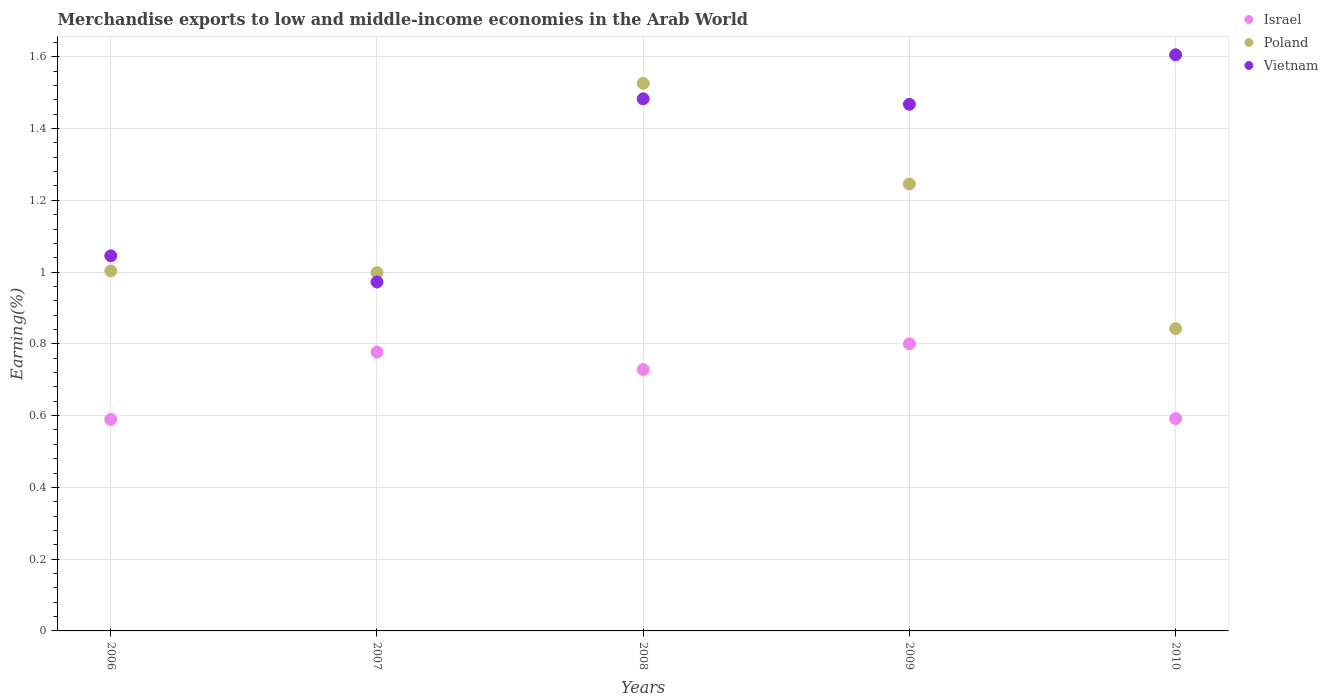How many different coloured dotlines are there?
Offer a very short reply. 3. Is the number of dotlines equal to the number of legend labels?
Offer a terse response. Yes. What is the percentage of amount earned from merchandise exports in Israel in 2006?
Give a very brief answer. 0.59. Across all years, what is the maximum percentage of amount earned from merchandise exports in Israel?
Provide a short and direct response. 0.8. Across all years, what is the minimum percentage of amount earned from merchandise exports in Poland?
Make the answer very short. 0.84. In which year was the percentage of amount earned from merchandise exports in Poland maximum?
Your answer should be very brief. 2008. What is the total percentage of amount earned from merchandise exports in Poland in the graph?
Give a very brief answer. 5.62. What is the difference between the percentage of amount earned from merchandise exports in Poland in 2007 and that in 2008?
Ensure brevity in your answer.  -0.53. What is the difference between the percentage of amount earned from merchandise exports in Vietnam in 2008 and the percentage of amount earned from merchandise exports in Israel in 2010?
Your response must be concise. 0.89. What is the average percentage of amount earned from merchandise exports in Vietnam per year?
Offer a very short reply. 1.31. In the year 2009, what is the difference between the percentage of amount earned from merchandise exports in Vietnam and percentage of amount earned from merchandise exports in Poland?
Give a very brief answer. 0.22. In how many years, is the percentage of amount earned from merchandise exports in Vietnam greater than 0.04 %?
Provide a short and direct response. 5. What is the ratio of the percentage of amount earned from merchandise exports in Israel in 2006 to that in 2010?
Ensure brevity in your answer.  1. Is the percentage of amount earned from merchandise exports in Vietnam in 2006 less than that in 2009?
Offer a very short reply. Yes. Is the difference between the percentage of amount earned from merchandise exports in Vietnam in 2006 and 2009 greater than the difference between the percentage of amount earned from merchandise exports in Poland in 2006 and 2009?
Make the answer very short. No. What is the difference between the highest and the second highest percentage of amount earned from merchandise exports in Vietnam?
Provide a succinct answer. 0.12. What is the difference between the highest and the lowest percentage of amount earned from merchandise exports in Poland?
Offer a very short reply. 0.68. Is the sum of the percentage of amount earned from merchandise exports in Israel in 2008 and 2009 greater than the maximum percentage of amount earned from merchandise exports in Vietnam across all years?
Your response must be concise. No. How many years are there in the graph?
Offer a very short reply. 5. Are the values on the major ticks of Y-axis written in scientific E-notation?
Offer a terse response. No. Does the graph contain any zero values?
Offer a terse response. No. Does the graph contain grids?
Your answer should be very brief. Yes. Where does the legend appear in the graph?
Your answer should be very brief. Top right. How many legend labels are there?
Provide a succinct answer. 3. How are the legend labels stacked?
Your answer should be compact. Vertical. What is the title of the graph?
Your answer should be compact. Merchandise exports to low and middle-income economies in the Arab World. Does "Curacao" appear as one of the legend labels in the graph?
Provide a short and direct response. No. What is the label or title of the Y-axis?
Ensure brevity in your answer.  Earning(%). What is the Earning(%) in Israel in 2006?
Keep it short and to the point. 0.59. What is the Earning(%) of Poland in 2006?
Provide a short and direct response. 1. What is the Earning(%) of Vietnam in 2006?
Keep it short and to the point. 1.05. What is the Earning(%) of Israel in 2007?
Your answer should be compact. 0.78. What is the Earning(%) in Poland in 2007?
Your answer should be compact. 1. What is the Earning(%) of Vietnam in 2007?
Your response must be concise. 0.97. What is the Earning(%) in Israel in 2008?
Your response must be concise. 0.73. What is the Earning(%) in Poland in 2008?
Provide a succinct answer. 1.53. What is the Earning(%) of Vietnam in 2008?
Your response must be concise. 1.48. What is the Earning(%) in Israel in 2009?
Offer a terse response. 0.8. What is the Earning(%) of Poland in 2009?
Make the answer very short. 1.25. What is the Earning(%) of Vietnam in 2009?
Offer a terse response. 1.47. What is the Earning(%) in Israel in 2010?
Make the answer very short. 0.59. What is the Earning(%) of Poland in 2010?
Your answer should be very brief. 0.84. What is the Earning(%) in Vietnam in 2010?
Provide a succinct answer. 1.61. Across all years, what is the maximum Earning(%) of Israel?
Ensure brevity in your answer.  0.8. Across all years, what is the maximum Earning(%) in Poland?
Make the answer very short. 1.53. Across all years, what is the maximum Earning(%) in Vietnam?
Your answer should be compact. 1.61. Across all years, what is the minimum Earning(%) in Israel?
Provide a short and direct response. 0.59. Across all years, what is the minimum Earning(%) in Poland?
Offer a terse response. 0.84. Across all years, what is the minimum Earning(%) in Vietnam?
Provide a succinct answer. 0.97. What is the total Earning(%) of Israel in the graph?
Your response must be concise. 3.49. What is the total Earning(%) of Poland in the graph?
Your response must be concise. 5.62. What is the total Earning(%) in Vietnam in the graph?
Provide a short and direct response. 6.57. What is the difference between the Earning(%) in Israel in 2006 and that in 2007?
Offer a terse response. -0.19. What is the difference between the Earning(%) in Poland in 2006 and that in 2007?
Provide a short and direct response. 0. What is the difference between the Earning(%) in Vietnam in 2006 and that in 2007?
Keep it short and to the point. 0.07. What is the difference between the Earning(%) of Israel in 2006 and that in 2008?
Provide a succinct answer. -0.14. What is the difference between the Earning(%) in Poland in 2006 and that in 2008?
Your answer should be compact. -0.52. What is the difference between the Earning(%) in Vietnam in 2006 and that in 2008?
Provide a short and direct response. -0.44. What is the difference between the Earning(%) of Israel in 2006 and that in 2009?
Provide a short and direct response. -0.21. What is the difference between the Earning(%) of Poland in 2006 and that in 2009?
Offer a terse response. -0.24. What is the difference between the Earning(%) of Vietnam in 2006 and that in 2009?
Your answer should be very brief. -0.42. What is the difference between the Earning(%) in Israel in 2006 and that in 2010?
Your answer should be very brief. -0. What is the difference between the Earning(%) of Poland in 2006 and that in 2010?
Give a very brief answer. 0.16. What is the difference between the Earning(%) of Vietnam in 2006 and that in 2010?
Your answer should be very brief. -0.56. What is the difference between the Earning(%) in Israel in 2007 and that in 2008?
Keep it short and to the point. 0.05. What is the difference between the Earning(%) of Poland in 2007 and that in 2008?
Provide a succinct answer. -0.53. What is the difference between the Earning(%) in Vietnam in 2007 and that in 2008?
Make the answer very short. -0.51. What is the difference between the Earning(%) of Israel in 2007 and that in 2009?
Provide a succinct answer. -0.02. What is the difference between the Earning(%) in Poland in 2007 and that in 2009?
Ensure brevity in your answer.  -0.25. What is the difference between the Earning(%) in Vietnam in 2007 and that in 2009?
Your answer should be compact. -0.5. What is the difference between the Earning(%) in Israel in 2007 and that in 2010?
Your response must be concise. 0.19. What is the difference between the Earning(%) in Poland in 2007 and that in 2010?
Keep it short and to the point. 0.16. What is the difference between the Earning(%) in Vietnam in 2007 and that in 2010?
Give a very brief answer. -0.63. What is the difference between the Earning(%) of Israel in 2008 and that in 2009?
Give a very brief answer. -0.07. What is the difference between the Earning(%) of Poland in 2008 and that in 2009?
Ensure brevity in your answer.  0.28. What is the difference between the Earning(%) in Vietnam in 2008 and that in 2009?
Give a very brief answer. 0.02. What is the difference between the Earning(%) in Israel in 2008 and that in 2010?
Your answer should be compact. 0.14. What is the difference between the Earning(%) of Poland in 2008 and that in 2010?
Your answer should be very brief. 0.68. What is the difference between the Earning(%) in Vietnam in 2008 and that in 2010?
Offer a terse response. -0.12. What is the difference between the Earning(%) in Israel in 2009 and that in 2010?
Provide a short and direct response. 0.21. What is the difference between the Earning(%) of Poland in 2009 and that in 2010?
Keep it short and to the point. 0.4. What is the difference between the Earning(%) in Vietnam in 2009 and that in 2010?
Your response must be concise. -0.14. What is the difference between the Earning(%) of Israel in 2006 and the Earning(%) of Poland in 2007?
Ensure brevity in your answer.  -0.41. What is the difference between the Earning(%) of Israel in 2006 and the Earning(%) of Vietnam in 2007?
Your answer should be very brief. -0.38. What is the difference between the Earning(%) of Poland in 2006 and the Earning(%) of Vietnam in 2007?
Provide a succinct answer. 0.03. What is the difference between the Earning(%) of Israel in 2006 and the Earning(%) of Poland in 2008?
Provide a short and direct response. -0.94. What is the difference between the Earning(%) in Israel in 2006 and the Earning(%) in Vietnam in 2008?
Keep it short and to the point. -0.89. What is the difference between the Earning(%) of Poland in 2006 and the Earning(%) of Vietnam in 2008?
Give a very brief answer. -0.48. What is the difference between the Earning(%) in Israel in 2006 and the Earning(%) in Poland in 2009?
Your answer should be compact. -0.66. What is the difference between the Earning(%) in Israel in 2006 and the Earning(%) in Vietnam in 2009?
Give a very brief answer. -0.88. What is the difference between the Earning(%) of Poland in 2006 and the Earning(%) of Vietnam in 2009?
Keep it short and to the point. -0.46. What is the difference between the Earning(%) of Israel in 2006 and the Earning(%) of Poland in 2010?
Your answer should be compact. -0.25. What is the difference between the Earning(%) in Israel in 2006 and the Earning(%) in Vietnam in 2010?
Offer a very short reply. -1.02. What is the difference between the Earning(%) in Poland in 2006 and the Earning(%) in Vietnam in 2010?
Make the answer very short. -0.6. What is the difference between the Earning(%) in Israel in 2007 and the Earning(%) in Poland in 2008?
Ensure brevity in your answer.  -0.75. What is the difference between the Earning(%) in Israel in 2007 and the Earning(%) in Vietnam in 2008?
Make the answer very short. -0.71. What is the difference between the Earning(%) of Poland in 2007 and the Earning(%) of Vietnam in 2008?
Your answer should be compact. -0.48. What is the difference between the Earning(%) in Israel in 2007 and the Earning(%) in Poland in 2009?
Ensure brevity in your answer.  -0.47. What is the difference between the Earning(%) of Israel in 2007 and the Earning(%) of Vietnam in 2009?
Give a very brief answer. -0.69. What is the difference between the Earning(%) of Poland in 2007 and the Earning(%) of Vietnam in 2009?
Ensure brevity in your answer.  -0.47. What is the difference between the Earning(%) in Israel in 2007 and the Earning(%) in Poland in 2010?
Offer a terse response. -0.07. What is the difference between the Earning(%) of Israel in 2007 and the Earning(%) of Vietnam in 2010?
Provide a succinct answer. -0.83. What is the difference between the Earning(%) in Poland in 2007 and the Earning(%) in Vietnam in 2010?
Offer a very short reply. -0.61. What is the difference between the Earning(%) of Israel in 2008 and the Earning(%) of Poland in 2009?
Give a very brief answer. -0.52. What is the difference between the Earning(%) of Israel in 2008 and the Earning(%) of Vietnam in 2009?
Provide a short and direct response. -0.74. What is the difference between the Earning(%) of Poland in 2008 and the Earning(%) of Vietnam in 2009?
Provide a succinct answer. 0.06. What is the difference between the Earning(%) in Israel in 2008 and the Earning(%) in Poland in 2010?
Your response must be concise. -0.11. What is the difference between the Earning(%) in Israel in 2008 and the Earning(%) in Vietnam in 2010?
Ensure brevity in your answer.  -0.88. What is the difference between the Earning(%) of Poland in 2008 and the Earning(%) of Vietnam in 2010?
Keep it short and to the point. -0.08. What is the difference between the Earning(%) in Israel in 2009 and the Earning(%) in Poland in 2010?
Provide a succinct answer. -0.04. What is the difference between the Earning(%) in Israel in 2009 and the Earning(%) in Vietnam in 2010?
Your response must be concise. -0.81. What is the difference between the Earning(%) in Poland in 2009 and the Earning(%) in Vietnam in 2010?
Keep it short and to the point. -0.36. What is the average Earning(%) of Israel per year?
Your answer should be very brief. 0.7. What is the average Earning(%) in Poland per year?
Give a very brief answer. 1.12. What is the average Earning(%) of Vietnam per year?
Ensure brevity in your answer.  1.31. In the year 2006, what is the difference between the Earning(%) in Israel and Earning(%) in Poland?
Provide a short and direct response. -0.41. In the year 2006, what is the difference between the Earning(%) of Israel and Earning(%) of Vietnam?
Your answer should be compact. -0.46. In the year 2006, what is the difference between the Earning(%) of Poland and Earning(%) of Vietnam?
Offer a terse response. -0.04. In the year 2007, what is the difference between the Earning(%) in Israel and Earning(%) in Poland?
Provide a short and direct response. -0.22. In the year 2007, what is the difference between the Earning(%) of Israel and Earning(%) of Vietnam?
Your response must be concise. -0.2. In the year 2007, what is the difference between the Earning(%) of Poland and Earning(%) of Vietnam?
Ensure brevity in your answer.  0.03. In the year 2008, what is the difference between the Earning(%) in Israel and Earning(%) in Poland?
Offer a very short reply. -0.8. In the year 2008, what is the difference between the Earning(%) in Israel and Earning(%) in Vietnam?
Your response must be concise. -0.75. In the year 2008, what is the difference between the Earning(%) in Poland and Earning(%) in Vietnam?
Your answer should be very brief. 0.04. In the year 2009, what is the difference between the Earning(%) in Israel and Earning(%) in Poland?
Ensure brevity in your answer.  -0.45. In the year 2009, what is the difference between the Earning(%) of Israel and Earning(%) of Vietnam?
Give a very brief answer. -0.67. In the year 2009, what is the difference between the Earning(%) of Poland and Earning(%) of Vietnam?
Offer a very short reply. -0.22. In the year 2010, what is the difference between the Earning(%) in Israel and Earning(%) in Poland?
Provide a succinct answer. -0.25. In the year 2010, what is the difference between the Earning(%) of Israel and Earning(%) of Vietnam?
Your answer should be compact. -1.01. In the year 2010, what is the difference between the Earning(%) of Poland and Earning(%) of Vietnam?
Offer a terse response. -0.76. What is the ratio of the Earning(%) in Israel in 2006 to that in 2007?
Keep it short and to the point. 0.76. What is the ratio of the Earning(%) of Vietnam in 2006 to that in 2007?
Ensure brevity in your answer.  1.07. What is the ratio of the Earning(%) in Israel in 2006 to that in 2008?
Give a very brief answer. 0.81. What is the ratio of the Earning(%) in Poland in 2006 to that in 2008?
Make the answer very short. 0.66. What is the ratio of the Earning(%) in Vietnam in 2006 to that in 2008?
Your response must be concise. 0.7. What is the ratio of the Earning(%) of Israel in 2006 to that in 2009?
Keep it short and to the point. 0.74. What is the ratio of the Earning(%) in Poland in 2006 to that in 2009?
Keep it short and to the point. 0.81. What is the ratio of the Earning(%) of Vietnam in 2006 to that in 2009?
Offer a terse response. 0.71. What is the ratio of the Earning(%) of Poland in 2006 to that in 2010?
Offer a very short reply. 1.19. What is the ratio of the Earning(%) in Vietnam in 2006 to that in 2010?
Provide a short and direct response. 0.65. What is the ratio of the Earning(%) in Israel in 2007 to that in 2008?
Provide a short and direct response. 1.07. What is the ratio of the Earning(%) of Poland in 2007 to that in 2008?
Ensure brevity in your answer.  0.65. What is the ratio of the Earning(%) of Vietnam in 2007 to that in 2008?
Your answer should be compact. 0.66. What is the ratio of the Earning(%) in Israel in 2007 to that in 2009?
Make the answer very short. 0.97. What is the ratio of the Earning(%) of Poland in 2007 to that in 2009?
Give a very brief answer. 0.8. What is the ratio of the Earning(%) in Vietnam in 2007 to that in 2009?
Provide a succinct answer. 0.66. What is the ratio of the Earning(%) in Israel in 2007 to that in 2010?
Provide a succinct answer. 1.31. What is the ratio of the Earning(%) in Poland in 2007 to that in 2010?
Provide a succinct answer. 1.19. What is the ratio of the Earning(%) in Vietnam in 2007 to that in 2010?
Offer a very short reply. 0.61. What is the ratio of the Earning(%) of Israel in 2008 to that in 2009?
Offer a terse response. 0.91. What is the ratio of the Earning(%) in Poland in 2008 to that in 2009?
Make the answer very short. 1.23. What is the ratio of the Earning(%) of Vietnam in 2008 to that in 2009?
Give a very brief answer. 1.01. What is the ratio of the Earning(%) in Israel in 2008 to that in 2010?
Your response must be concise. 1.23. What is the ratio of the Earning(%) of Poland in 2008 to that in 2010?
Your response must be concise. 1.81. What is the ratio of the Earning(%) in Vietnam in 2008 to that in 2010?
Your answer should be very brief. 0.92. What is the ratio of the Earning(%) in Israel in 2009 to that in 2010?
Your answer should be compact. 1.35. What is the ratio of the Earning(%) in Poland in 2009 to that in 2010?
Give a very brief answer. 1.48. What is the ratio of the Earning(%) in Vietnam in 2009 to that in 2010?
Make the answer very short. 0.91. What is the difference between the highest and the second highest Earning(%) of Israel?
Provide a succinct answer. 0.02. What is the difference between the highest and the second highest Earning(%) in Poland?
Provide a short and direct response. 0.28. What is the difference between the highest and the second highest Earning(%) in Vietnam?
Your answer should be compact. 0.12. What is the difference between the highest and the lowest Earning(%) in Israel?
Your answer should be compact. 0.21. What is the difference between the highest and the lowest Earning(%) of Poland?
Make the answer very short. 0.68. What is the difference between the highest and the lowest Earning(%) of Vietnam?
Offer a terse response. 0.63. 